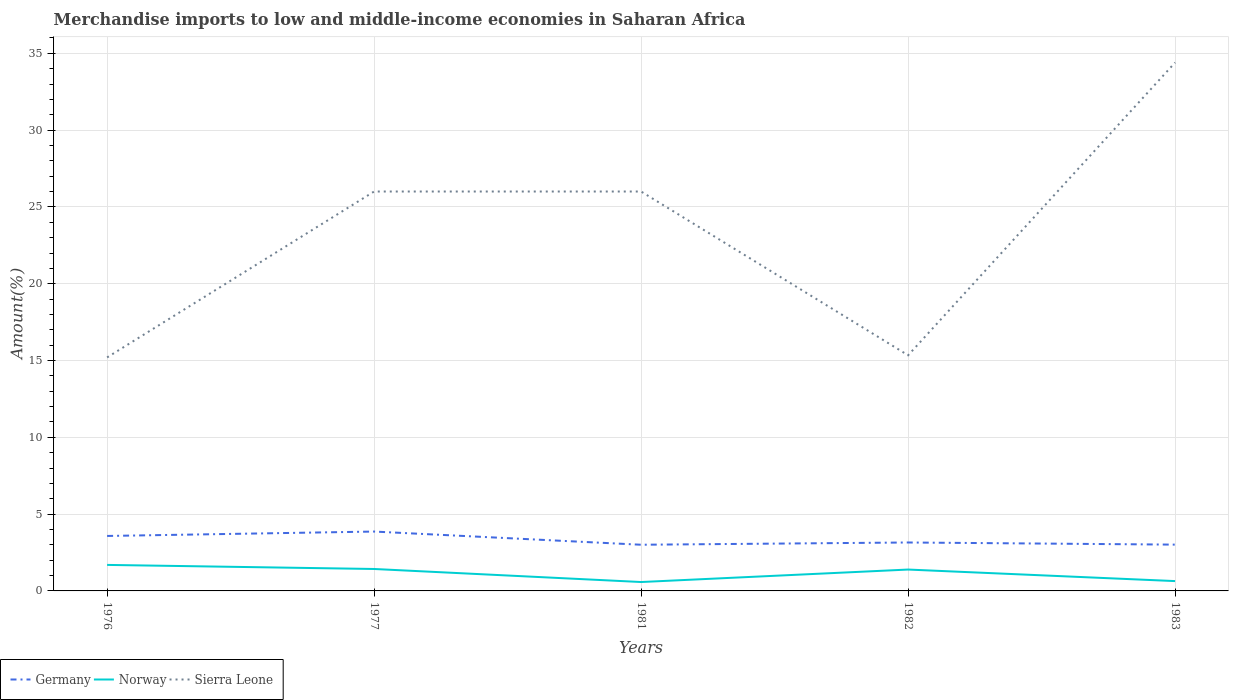How many different coloured lines are there?
Give a very brief answer. 3. Is the number of lines equal to the number of legend labels?
Your response must be concise. Yes. Across all years, what is the maximum percentage of amount earned from merchandise imports in Sierra Leone?
Keep it short and to the point. 15.2. What is the total percentage of amount earned from merchandise imports in Germany in the graph?
Give a very brief answer. 0.42. What is the difference between the highest and the second highest percentage of amount earned from merchandise imports in Norway?
Give a very brief answer. 1.11. What is the difference between the highest and the lowest percentage of amount earned from merchandise imports in Germany?
Give a very brief answer. 2. Is the percentage of amount earned from merchandise imports in Norway strictly greater than the percentage of amount earned from merchandise imports in Germany over the years?
Give a very brief answer. Yes. Are the values on the major ticks of Y-axis written in scientific E-notation?
Your answer should be compact. No. Does the graph contain grids?
Ensure brevity in your answer.  Yes. What is the title of the graph?
Provide a short and direct response. Merchandise imports to low and middle-income economies in Saharan Africa. What is the label or title of the X-axis?
Ensure brevity in your answer.  Years. What is the label or title of the Y-axis?
Keep it short and to the point. Amount(%). What is the Amount(%) of Germany in 1976?
Offer a terse response. 3.58. What is the Amount(%) in Norway in 1976?
Keep it short and to the point. 1.69. What is the Amount(%) of Sierra Leone in 1976?
Offer a very short reply. 15.2. What is the Amount(%) in Germany in 1977?
Ensure brevity in your answer.  3.87. What is the Amount(%) of Norway in 1977?
Give a very brief answer. 1.43. What is the Amount(%) of Sierra Leone in 1977?
Provide a short and direct response. 26. What is the Amount(%) of Germany in 1981?
Give a very brief answer. 3.01. What is the Amount(%) in Norway in 1981?
Keep it short and to the point. 0.58. What is the Amount(%) in Sierra Leone in 1981?
Provide a short and direct response. 26. What is the Amount(%) in Germany in 1982?
Provide a short and direct response. 3.15. What is the Amount(%) of Norway in 1982?
Give a very brief answer. 1.39. What is the Amount(%) of Sierra Leone in 1982?
Ensure brevity in your answer.  15.34. What is the Amount(%) of Germany in 1983?
Offer a terse response. 3.01. What is the Amount(%) in Norway in 1983?
Make the answer very short. 0.64. What is the Amount(%) of Sierra Leone in 1983?
Your response must be concise. 34.4. Across all years, what is the maximum Amount(%) of Germany?
Offer a very short reply. 3.87. Across all years, what is the maximum Amount(%) in Norway?
Ensure brevity in your answer.  1.69. Across all years, what is the maximum Amount(%) in Sierra Leone?
Your answer should be compact. 34.4. Across all years, what is the minimum Amount(%) of Germany?
Ensure brevity in your answer.  3.01. Across all years, what is the minimum Amount(%) in Norway?
Provide a short and direct response. 0.58. Across all years, what is the minimum Amount(%) in Sierra Leone?
Your answer should be compact. 15.2. What is the total Amount(%) in Germany in the graph?
Provide a short and direct response. 16.62. What is the total Amount(%) in Norway in the graph?
Make the answer very short. 5.73. What is the total Amount(%) in Sierra Leone in the graph?
Ensure brevity in your answer.  116.95. What is the difference between the Amount(%) of Germany in 1976 and that in 1977?
Ensure brevity in your answer.  -0.29. What is the difference between the Amount(%) of Norway in 1976 and that in 1977?
Your answer should be very brief. 0.26. What is the difference between the Amount(%) in Sierra Leone in 1976 and that in 1977?
Your answer should be very brief. -10.8. What is the difference between the Amount(%) in Germany in 1976 and that in 1981?
Your response must be concise. 0.57. What is the difference between the Amount(%) in Norway in 1976 and that in 1981?
Your response must be concise. 1.11. What is the difference between the Amount(%) of Sierra Leone in 1976 and that in 1981?
Offer a terse response. -10.8. What is the difference between the Amount(%) of Germany in 1976 and that in 1982?
Your answer should be very brief. 0.42. What is the difference between the Amount(%) of Norway in 1976 and that in 1982?
Your answer should be compact. 0.3. What is the difference between the Amount(%) in Sierra Leone in 1976 and that in 1982?
Your answer should be very brief. -0.14. What is the difference between the Amount(%) in Germany in 1976 and that in 1983?
Provide a succinct answer. 0.56. What is the difference between the Amount(%) of Norway in 1976 and that in 1983?
Give a very brief answer. 1.05. What is the difference between the Amount(%) in Sierra Leone in 1976 and that in 1983?
Give a very brief answer. -19.2. What is the difference between the Amount(%) of Germany in 1977 and that in 1981?
Give a very brief answer. 0.86. What is the difference between the Amount(%) in Norway in 1977 and that in 1981?
Ensure brevity in your answer.  0.85. What is the difference between the Amount(%) of Germany in 1977 and that in 1982?
Your answer should be very brief. 0.71. What is the difference between the Amount(%) in Norway in 1977 and that in 1982?
Ensure brevity in your answer.  0.04. What is the difference between the Amount(%) in Sierra Leone in 1977 and that in 1982?
Your response must be concise. 10.66. What is the difference between the Amount(%) in Germany in 1977 and that in 1983?
Offer a very short reply. 0.85. What is the difference between the Amount(%) in Norway in 1977 and that in 1983?
Provide a short and direct response. 0.79. What is the difference between the Amount(%) in Sierra Leone in 1977 and that in 1983?
Your answer should be compact. -8.4. What is the difference between the Amount(%) in Germany in 1981 and that in 1982?
Make the answer very short. -0.15. What is the difference between the Amount(%) of Norway in 1981 and that in 1982?
Offer a very short reply. -0.81. What is the difference between the Amount(%) in Sierra Leone in 1981 and that in 1982?
Provide a short and direct response. 10.66. What is the difference between the Amount(%) in Germany in 1981 and that in 1983?
Your answer should be compact. -0.01. What is the difference between the Amount(%) in Norway in 1981 and that in 1983?
Make the answer very short. -0.06. What is the difference between the Amount(%) of Sierra Leone in 1981 and that in 1983?
Make the answer very short. -8.4. What is the difference between the Amount(%) of Germany in 1982 and that in 1983?
Ensure brevity in your answer.  0.14. What is the difference between the Amount(%) of Norway in 1982 and that in 1983?
Your answer should be very brief. 0.75. What is the difference between the Amount(%) of Sierra Leone in 1982 and that in 1983?
Your response must be concise. -19.06. What is the difference between the Amount(%) of Germany in 1976 and the Amount(%) of Norway in 1977?
Ensure brevity in your answer.  2.15. What is the difference between the Amount(%) in Germany in 1976 and the Amount(%) in Sierra Leone in 1977?
Ensure brevity in your answer.  -22.43. What is the difference between the Amount(%) of Norway in 1976 and the Amount(%) of Sierra Leone in 1977?
Provide a short and direct response. -24.31. What is the difference between the Amount(%) of Germany in 1976 and the Amount(%) of Norway in 1981?
Make the answer very short. 3. What is the difference between the Amount(%) in Germany in 1976 and the Amount(%) in Sierra Leone in 1981?
Provide a succinct answer. -22.43. What is the difference between the Amount(%) of Norway in 1976 and the Amount(%) of Sierra Leone in 1981?
Your answer should be compact. -24.31. What is the difference between the Amount(%) of Germany in 1976 and the Amount(%) of Norway in 1982?
Offer a terse response. 2.19. What is the difference between the Amount(%) of Germany in 1976 and the Amount(%) of Sierra Leone in 1982?
Offer a terse response. -11.76. What is the difference between the Amount(%) in Norway in 1976 and the Amount(%) in Sierra Leone in 1982?
Provide a succinct answer. -13.65. What is the difference between the Amount(%) of Germany in 1976 and the Amount(%) of Norway in 1983?
Provide a short and direct response. 2.94. What is the difference between the Amount(%) in Germany in 1976 and the Amount(%) in Sierra Leone in 1983?
Offer a very short reply. -30.82. What is the difference between the Amount(%) in Norway in 1976 and the Amount(%) in Sierra Leone in 1983?
Your answer should be very brief. -32.71. What is the difference between the Amount(%) in Germany in 1977 and the Amount(%) in Norway in 1981?
Your answer should be compact. 3.29. What is the difference between the Amount(%) of Germany in 1977 and the Amount(%) of Sierra Leone in 1981?
Your answer should be compact. -22.14. What is the difference between the Amount(%) of Norway in 1977 and the Amount(%) of Sierra Leone in 1981?
Ensure brevity in your answer.  -24.58. What is the difference between the Amount(%) in Germany in 1977 and the Amount(%) in Norway in 1982?
Provide a short and direct response. 2.47. What is the difference between the Amount(%) in Germany in 1977 and the Amount(%) in Sierra Leone in 1982?
Offer a terse response. -11.48. What is the difference between the Amount(%) in Norway in 1977 and the Amount(%) in Sierra Leone in 1982?
Give a very brief answer. -13.91. What is the difference between the Amount(%) of Germany in 1977 and the Amount(%) of Norway in 1983?
Offer a terse response. 3.23. What is the difference between the Amount(%) of Germany in 1977 and the Amount(%) of Sierra Leone in 1983?
Your answer should be very brief. -30.54. What is the difference between the Amount(%) in Norway in 1977 and the Amount(%) in Sierra Leone in 1983?
Offer a very short reply. -32.97. What is the difference between the Amount(%) in Germany in 1981 and the Amount(%) in Norway in 1982?
Offer a terse response. 1.62. What is the difference between the Amount(%) of Germany in 1981 and the Amount(%) of Sierra Leone in 1982?
Offer a very short reply. -12.33. What is the difference between the Amount(%) in Norway in 1981 and the Amount(%) in Sierra Leone in 1982?
Your answer should be very brief. -14.76. What is the difference between the Amount(%) of Germany in 1981 and the Amount(%) of Norway in 1983?
Keep it short and to the point. 2.37. What is the difference between the Amount(%) in Germany in 1981 and the Amount(%) in Sierra Leone in 1983?
Give a very brief answer. -31.39. What is the difference between the Amount(%) in Norway in 1981 and the Amount(%) in Sierra Leone in 1983?
Keep it short and to the point. -33.82. What is the difference between the Amount(%) of Germany in 1982 and the Amount(%) of Norway in 1983?
Give a very brief answer. 2.51. What is the difference between the Amount(%) in Germany in 1982 and the Amount(%) in Sierra Leone in 1983?
Make the answer very short. -31.25. What is the difference between the Amount(%) of Norway in 1982 and the Amount(%) of Sierra Leone in 1983?
Your answer should be very brief. -33.01. What is the average Amount(%) of Germany per year?
Give a very brief answer. 3.32. What is the average Amount(%) in Norway per year?
Keep it short and to the point. 1.15. What is the average Amount(%) in Sierra Leone per year?
Your answer should be very brief. 23.39. In the year 1976, what is the difference between the Amount(%) of Germany and Amount(%) of Norway?
Keep it short and to the point. 1.89. In the year 1976, what is the difference between the Amount(%) of Germany and Amount(%) of Sierra Leone?
Offer a very short reply. -11.62. In the year 1976, what is the difference between the Amount(%) of Norway and Amount(%) of Sierra Leone?
Keep it short and to the point. -13.51. In the year 1977, what is the difference between the Amount(%) in Germany and Amount(%) in Norway?
Provide a short and direct response. 2.44. In the year 1977, what is the difference between the Amount(%) of Germany and Amount(%) of Sierra Leone?
Give a very brief answer. -22.14. In the year 1977, what is the difference between the Amount(%) in Norway and Amount(%) in Sierra Leone?
Offer a very short reply. -24.58. In the year 1981, what is the difference between the Amount(%) in Germany and Amount(%) in Norway?
Offer a very short reply. 2.43. In the year 1981, what is the difference between the Amount(%) in Germany and Amount(%) in Sierra Leone?
Make the answer very short. -23. In the year 1981, what is the difference between the Amount(%) of Norway and Amount(%) of Sierra Leone?
Provide a short and direct response. -25.42. In the year 1982, what is the difference between the Amount(%) in Germany and Amount(%) in Norway?
Your answer should be very brief. 1.76. In the year 1982, what is the difference between the Amount(%) of Germany and Amount(%) of Sierra Leone?
Provide a short and direct response. -12.19. In the year 1982, what is the difference between the Amount(%) in Norway and Amount(%) in Sierra Leone?
Your answer should be very brief. -13.95. In the year 1983, what is the difference between the Amount(%) in Germany and Amount(%) in Norway?
Provide a succinct answer. 2.37. In the year 1983, what is the difference between the Amount(%) in Germany and Amount(%) in Sierra Leone?
Your answer should be very brief. -31.39. In the year 1983, what is the difference between the Amount(%) of Norway and Amount(%) of Sierra Leone?
Make the answer very short. -33.76. What is the ratio of the Amount(%) in Germany in 1976 to that in 1977?
Keep it short and to the point. 0.93. What is the ratio of the Amount(%) in Norway in 1976 to that in 1977?
Offer a terse response. 1.19. What is the ratio of the Amount(%) in Sierra Leone in 1976 to that in 1977?
Offer a terse response. 0.58. What is the ratio of the Amount(%) of Germany in 1976 to that in 1981?
Make the answer very short. 1.19. What is the ratio of the Amount(%) in Norway in 1976 to that in 1981?
Give a very brief answer. 2.92. What is the ratio of the Amount(%) of Sierra Leone in 1976 to that in 1981?
Provide a short and direct response. 0.58. What is the ratio of the Amount(%) of Germany in 1976 to that in 1982?
Make the answer very short. 1.13. What is the ratio of the Amount(%) of Norway in 1976 to that in 1982?
Provide a succinct answer. 1.22. What is the ratio of the Amount(%) in Germany in 1976 to that in 1983?
Ensure brevity in your answer.  1.19. What is the ratio of the Amount(%) of Norway in 1976 to that in 1983?
Your answer should be compact. 2.65. What is the ratio of the Amount(%) in Sierra Leone in 1976 to that in 1983?
Your answer should be compact. 0.44. What is the ratio of the Amount(%) in Norway in 1977 to that in 1981?
Your response must be concise. 2.47. What is the ratio of the Amount(%) in Sierra Leone in 1977 to that in 1981?
Offer a very short reply. 1. What is the ratio of the Amount(%) in Germany in 1977 to that in 1982?
Give a very brief answer. 1.23. What is the ratio of the Amount(%) of Norway in 1977 to that in 1982?
Your answer should be compact. 1.03. What is the ratio of the Amount(%) in Sierra Leone in 1977 to that in 1982?
Keep it short and to the point. 1.7. What is the ratio of the Amount(%) of Germany in 1977 to that in 1983?
Provide a succinct answer. 1.28. What is the ratio of the Amount(%) in Norway in 1977 to that in 1983?
Ensure brevity in your answer.  2.23. What is the ratio of the Amount(%) in Sierra Leone in 1977 to that in 1983?
Offer a terse response. 0.76. What is the ratio of the Amount(%) in Germany in 1981 to that in 1982?
Ensure brevity in your answer.  0.95. What is the ratio of the Amount(%) in Norway in 1981 to that in 1982?
Provide a short and direct response. 0.42. What is the ratio of the Amount(%) in Sierra Leone in 1981 to that in 1982?
Offer a terse response. 1.7. What is the ratio of the Amount(%) in Norway in 1981 to that in 1983?
Give a very brief answer. 0.91. What is the ratio of the Amount(%) of Sierra Leone in 1981 to that in 1983?
Make the answer very short. 0.76. What is the ratio of the Amount(%) of Germany in 1982 to that in 1983?
Ensure brevity in your answer.  1.05. What is the ratio of the Amount(%) of Norway in 1982 to that in 1983?
Your answer should be compact. 2.18. What is the ratio of the Amount(%) of Sierra Leone in 1982 to that in 1983?
Give a very brief answer. 0.45. What is the difference between the highest and the second highest Amount(%) in Germany?
Provide a succinct answer. 0.29. What is the difference between the highest and the second highest Amount(%) of Norway?
Make the answer very short. 0.26. What is the difference between the highest and the second highest Amount(%) of Sierra Leone?
Ensure brevity in your answer.  8.4. What is the difference between the highest and the lowest Amount(%) of Germany?
Provide a short and direct response. 0.86. What is the difference between the highest and the lowest Amount(%) of Norway?
Give a very brief answer. 1.11. What is the difference between the highest and the lowest Amount(%) of Sierra Leone?
Your response must be concise. 19.2. 